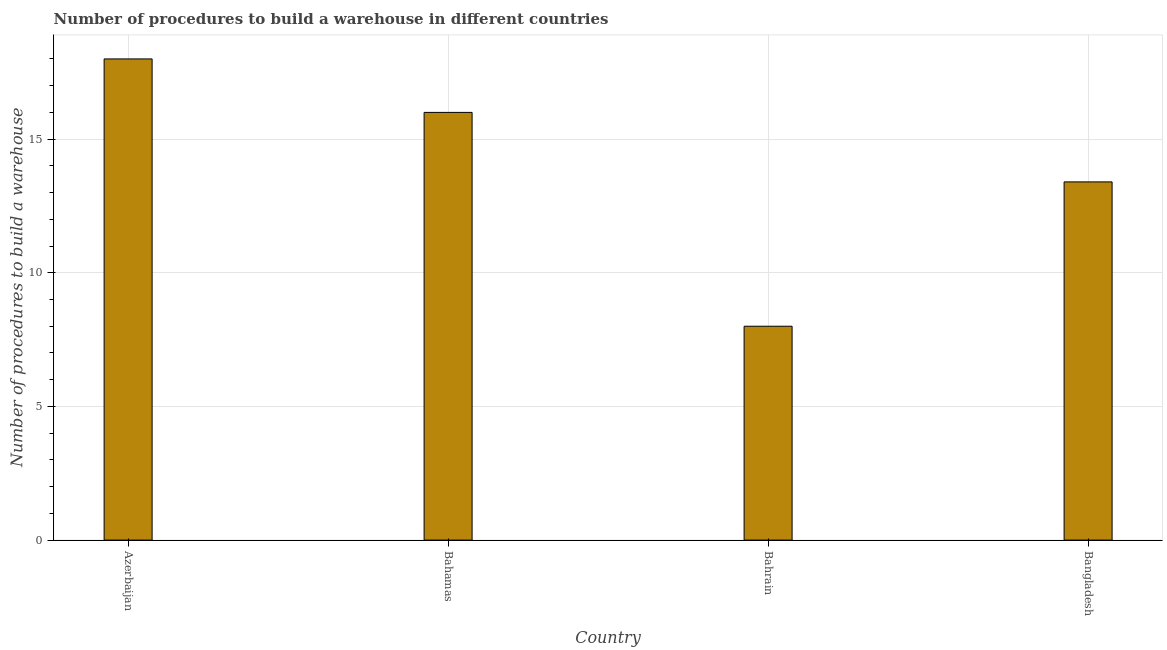What is the title of the graph?
Your response must be concise. Number of procedures to build a warehouse in different countries. What is the label or title of the X-axis?
Make the answer very short. Country. What is the label or title of the Y-axis?
Your response must be concise. Number of procedures to build a warehouse. What is the number of procedures to build a warehouse in Bahamas?
Make the answer very short. 16. Across all countries, what is the minimum number of procedures to build a warehouse?
Keep it short and to the point. 8. In which country was the number of procedures to build a warehouse maximum?
Your answer should be very brief. Azerbaijan. In which country was the number of procedures to build a warehouse minimum?
Your answer should be compact. Bahrain. What is the sum of the number of procedures to build a warehouse?
Provide a succinct answer. 55.4. What is the average number of procedures to build a warehouse per country?
Your response must be concise. 13.85. In how many countries, is the number of procedures to build a warehouse greater than 16 ?
Give a very brief answer. 1. What is the ratio of the number of procedures to build a warehouse in Azerbaijan to that in Bangladesh?
Give a very brief answer. 1.34. Is the difference between the number of procedures to build a warehouse in Bahrain and Bangladesh greater than the difference between any two countries?
Your answer should be compact. No. Is the sum of the number of procedures to build a warehouse in Azerbaijan and Bangladesh greater than the maximum number of procedures to build a warehouse across all countries?
Provide a short and direct response. Yes. What is the difference between the highest and the lowest number of procedures to build a warehouse?
Your answer should be very brief. 10. How many bars are there?
Provide a short and direct response. 4. Are all the bars in the graph horizontal?
Offer a terse response. No. How many countries are there in the graph?
Offer a terse response. 4. What is the Number of procedures to build a warehouse of Azerbaijan?
Offer a terse response. 18. What is the Number of procedures to build a warehouse in Bahamas?
Your answer should be compact. 16. What is the Number of procedures to build a warehouse of Bahrain?
Give a very brief answer. 8. What is the Number of procedures to build a warehouse in Bangladesh?
Your answer should be very brief. 13.4. What is the difference between the Number of procedures to build a warehouse in Azerbaijan and Bahamas?
Give a very brief answer. 2. What is the difference between the Number of procedures to build a warehouse in Azerbaijan and Bangladesh?
Your answer should be compact. 4.6. What is the difference between the Number of procedures to build a warehouse in Bahamas and Bahrain?
Keep it short and to the point. 8. What is the ratio of the Number of procedures to build a warehouse in Azerbaijan to that in Bahamas?
Your answer should be compact. 1.12. What is the ratio of the Number of procedures to build a warehouse in Azerbaijan to that in Bahrain?
Your answer should be very brief. 2.25. What is the ratio of the Number of procedures to build a warehouse in Azerbaijan to that in Bangladesh?
Provide a succinct answer. 1.34. What is the ratio of the Number of procedures to build a warehouse in Bahamas to that in Bahrain?
Provide a short and direct response. 2. What is the ratio of the Number of procedures to build a warehouse in Bahamas to that in Bangladesh?
Offer a terse response. 1.19. What is the ratio of the Number of procedures to build a warehouse in Bahrain to that in Bangladesh?
Offer a very short reply. 0.6. 